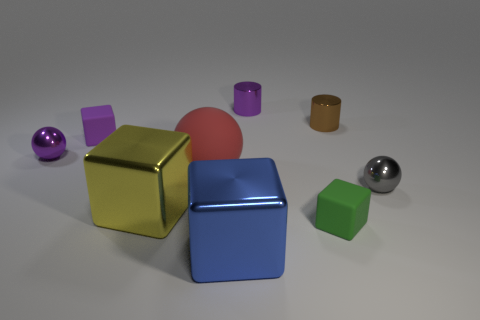Add 1 metal cylinders. How many objects exist? 10 Subtract all blocks. How many objects are left? 5 Subtract all red objects. Subtract all big spheres. How many objects are left? 7 Add 2 tiny metal objects. How many tiny metal objects are left? 6 Add 4 yellow things. How many yellow things exist? 5 Subtract 0 cyan balls. How many objects are left? 9 